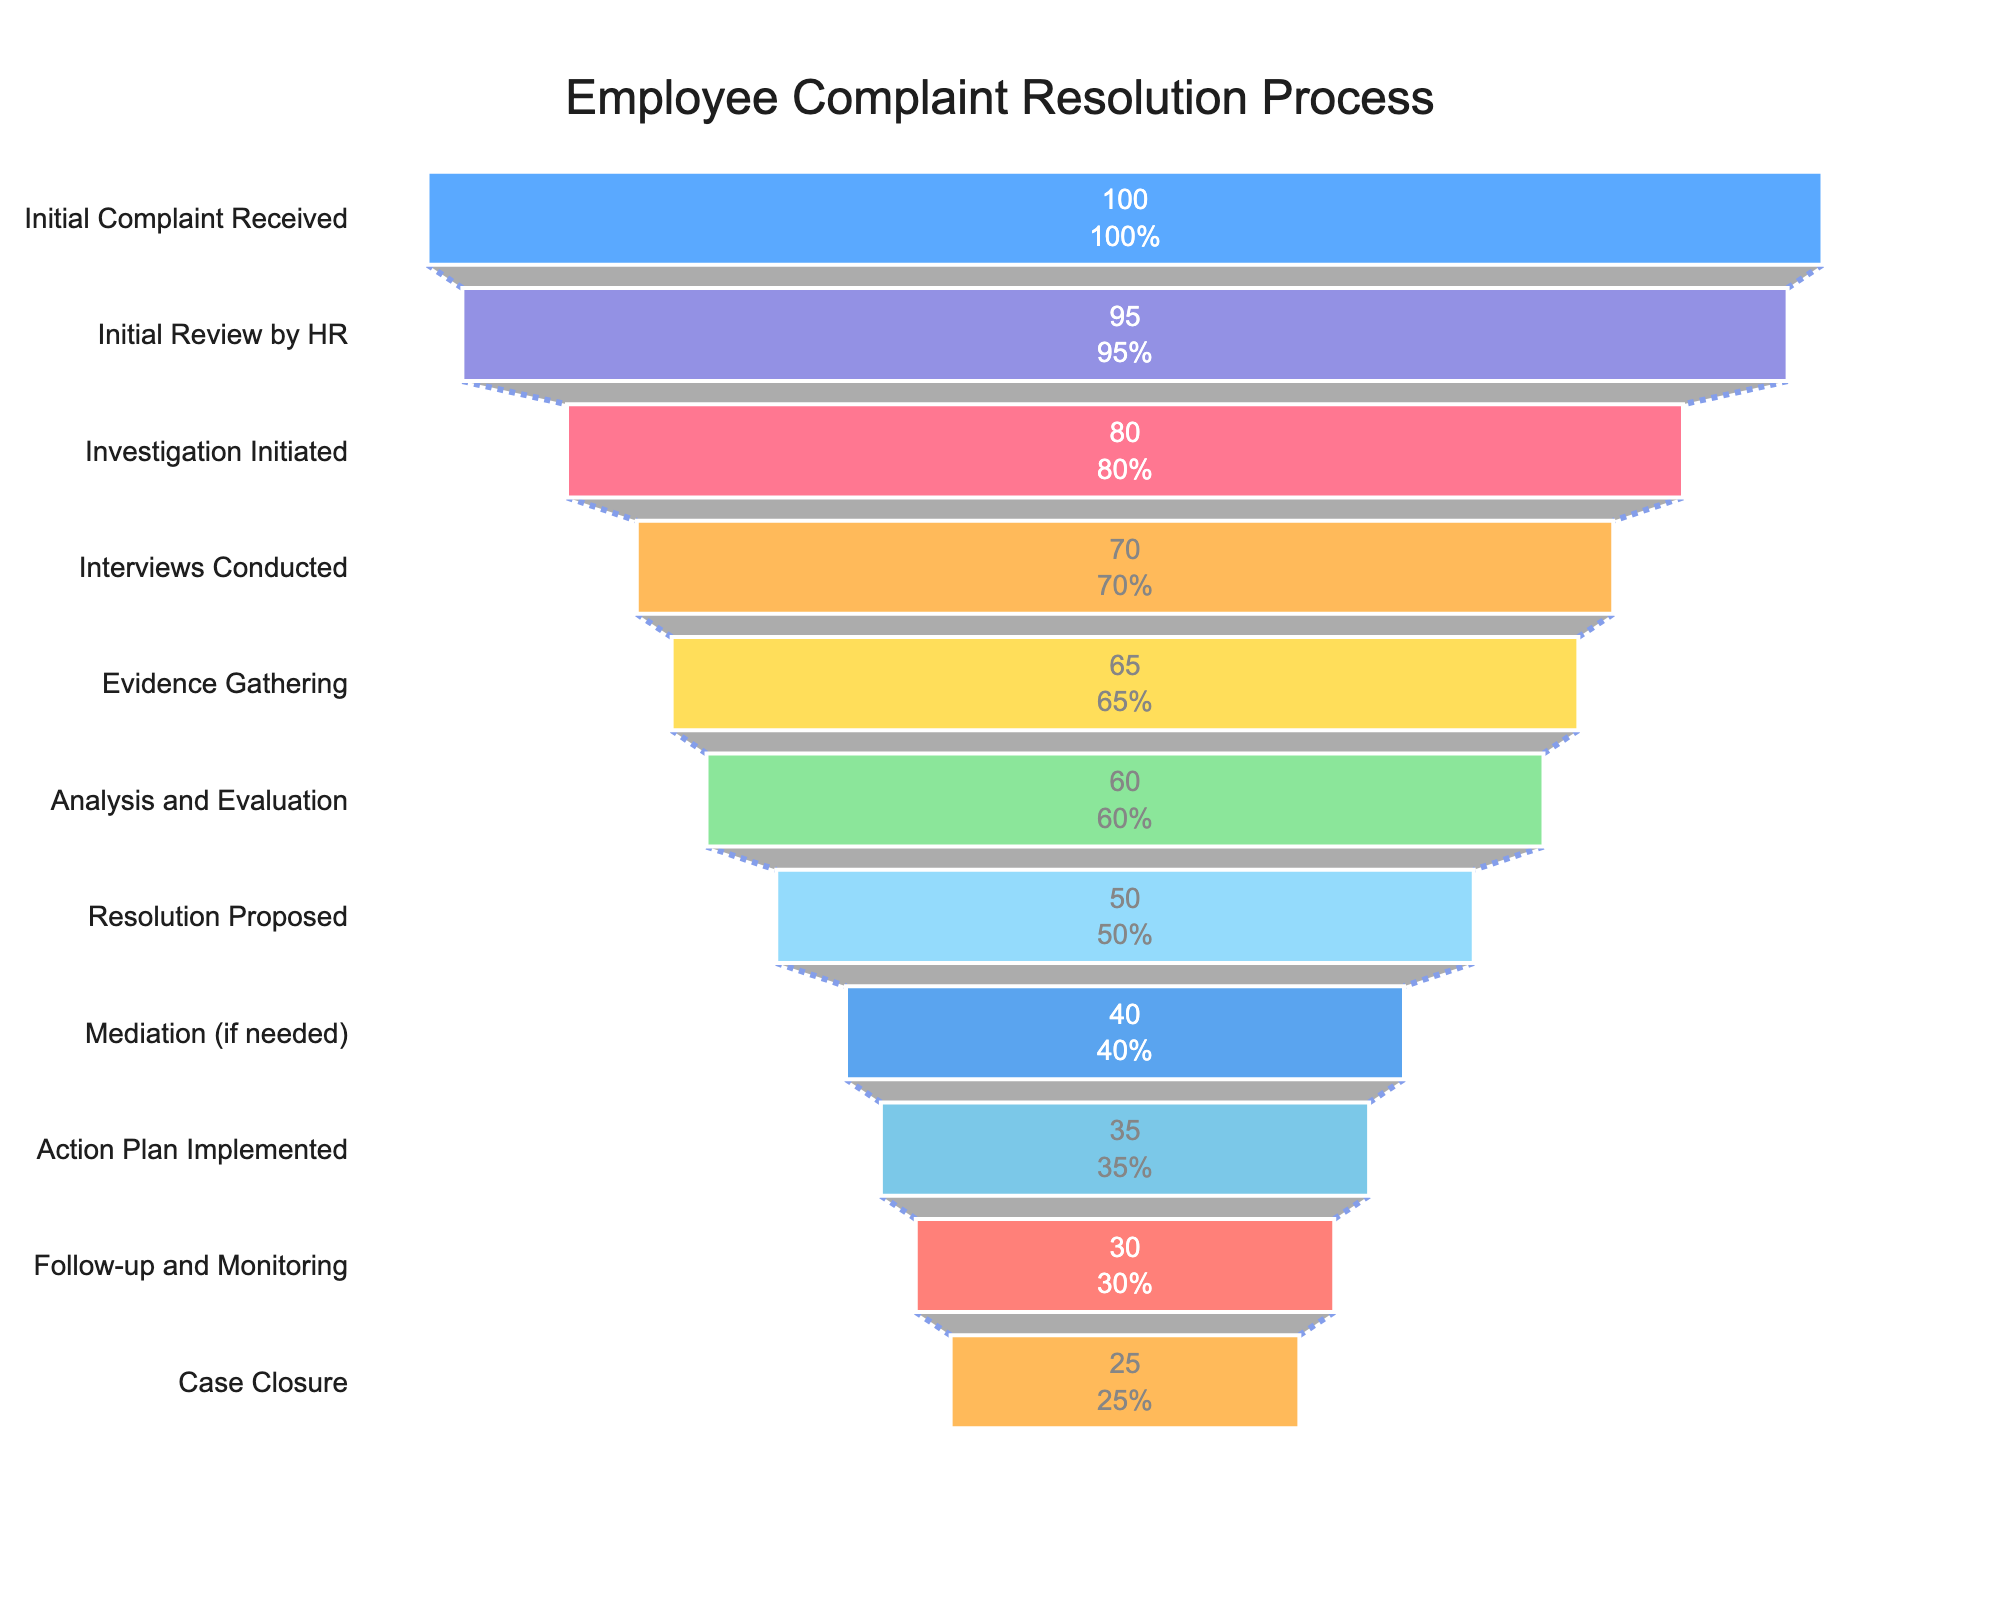How many cases remain at the Case Closure step? According to the figure, the number of cases at the "Case Closure" step is directly shown.
Answer: 25 How many initial complaints were received? The figure displays the number of initial complaints received in the first step labeled "Initial Complaint Received".
Answer: 100 What percentage of cases move from Initial Review by HR to Investigation Initiated? From the figure, 95 cases go through Initial Review by HR and 80 proceed to Investigation Initiated. The percentage is calculated as (80/95) * 100.
Answer: 84.21% How many steps are there in the employee complaint resolution process? The figure outlines each step, and by counting them, there are eleven steps in total.
Answer: 11 What is the difference in the number of cases between Analysis and Evaluation and Resolution Proposed? The figure shows 60 cases at Analysis and Evaluation and 50 at Resolution Proposed, thus the difference is 60 - 50.
Answer: 10 Which step sees the largest drop in the number of cases? The figure shows the number of cases at each step. By comparing the differences, the largest drop is from Initial Review by HR (95) to Investigation Initiated (80), a difference of 15 cases.
Answer: Initial Review by HR to Investigation Initiated At which step do less than 50% of the initial cases remain? There were 100 initial complaints. To find where less than 50% remain, look for the step where cases are fewer than 50. This occurs at Resolution Proposed with 50 cases.
Answer: Mediation (if needed) Between which two consecutive steps is the smallest reduction in the number of cases? The figure shows the number of cases at each step. By examining the reductions, the smallest reduction is between Evidence Gathering (65) and Analysis and Evaluation (60), a difference of 5 cases.
Answer: Evidence Gathering to Analysis and Evaluation What percentage of initial complaints result in Interviews Conducted? The figure shows 100 initial complaints and 70 cases where interviews were conducted. The percentage is calculated as (70/100) * 100.
Answer: 70% By how many cases do Action Plan Implemented cases decrease from Mediation cases? From the figure, there are 40 cases at Mediation and 35 cases at Action Plan Implemented. The decrease is 40 - 35.
Answer: 5 